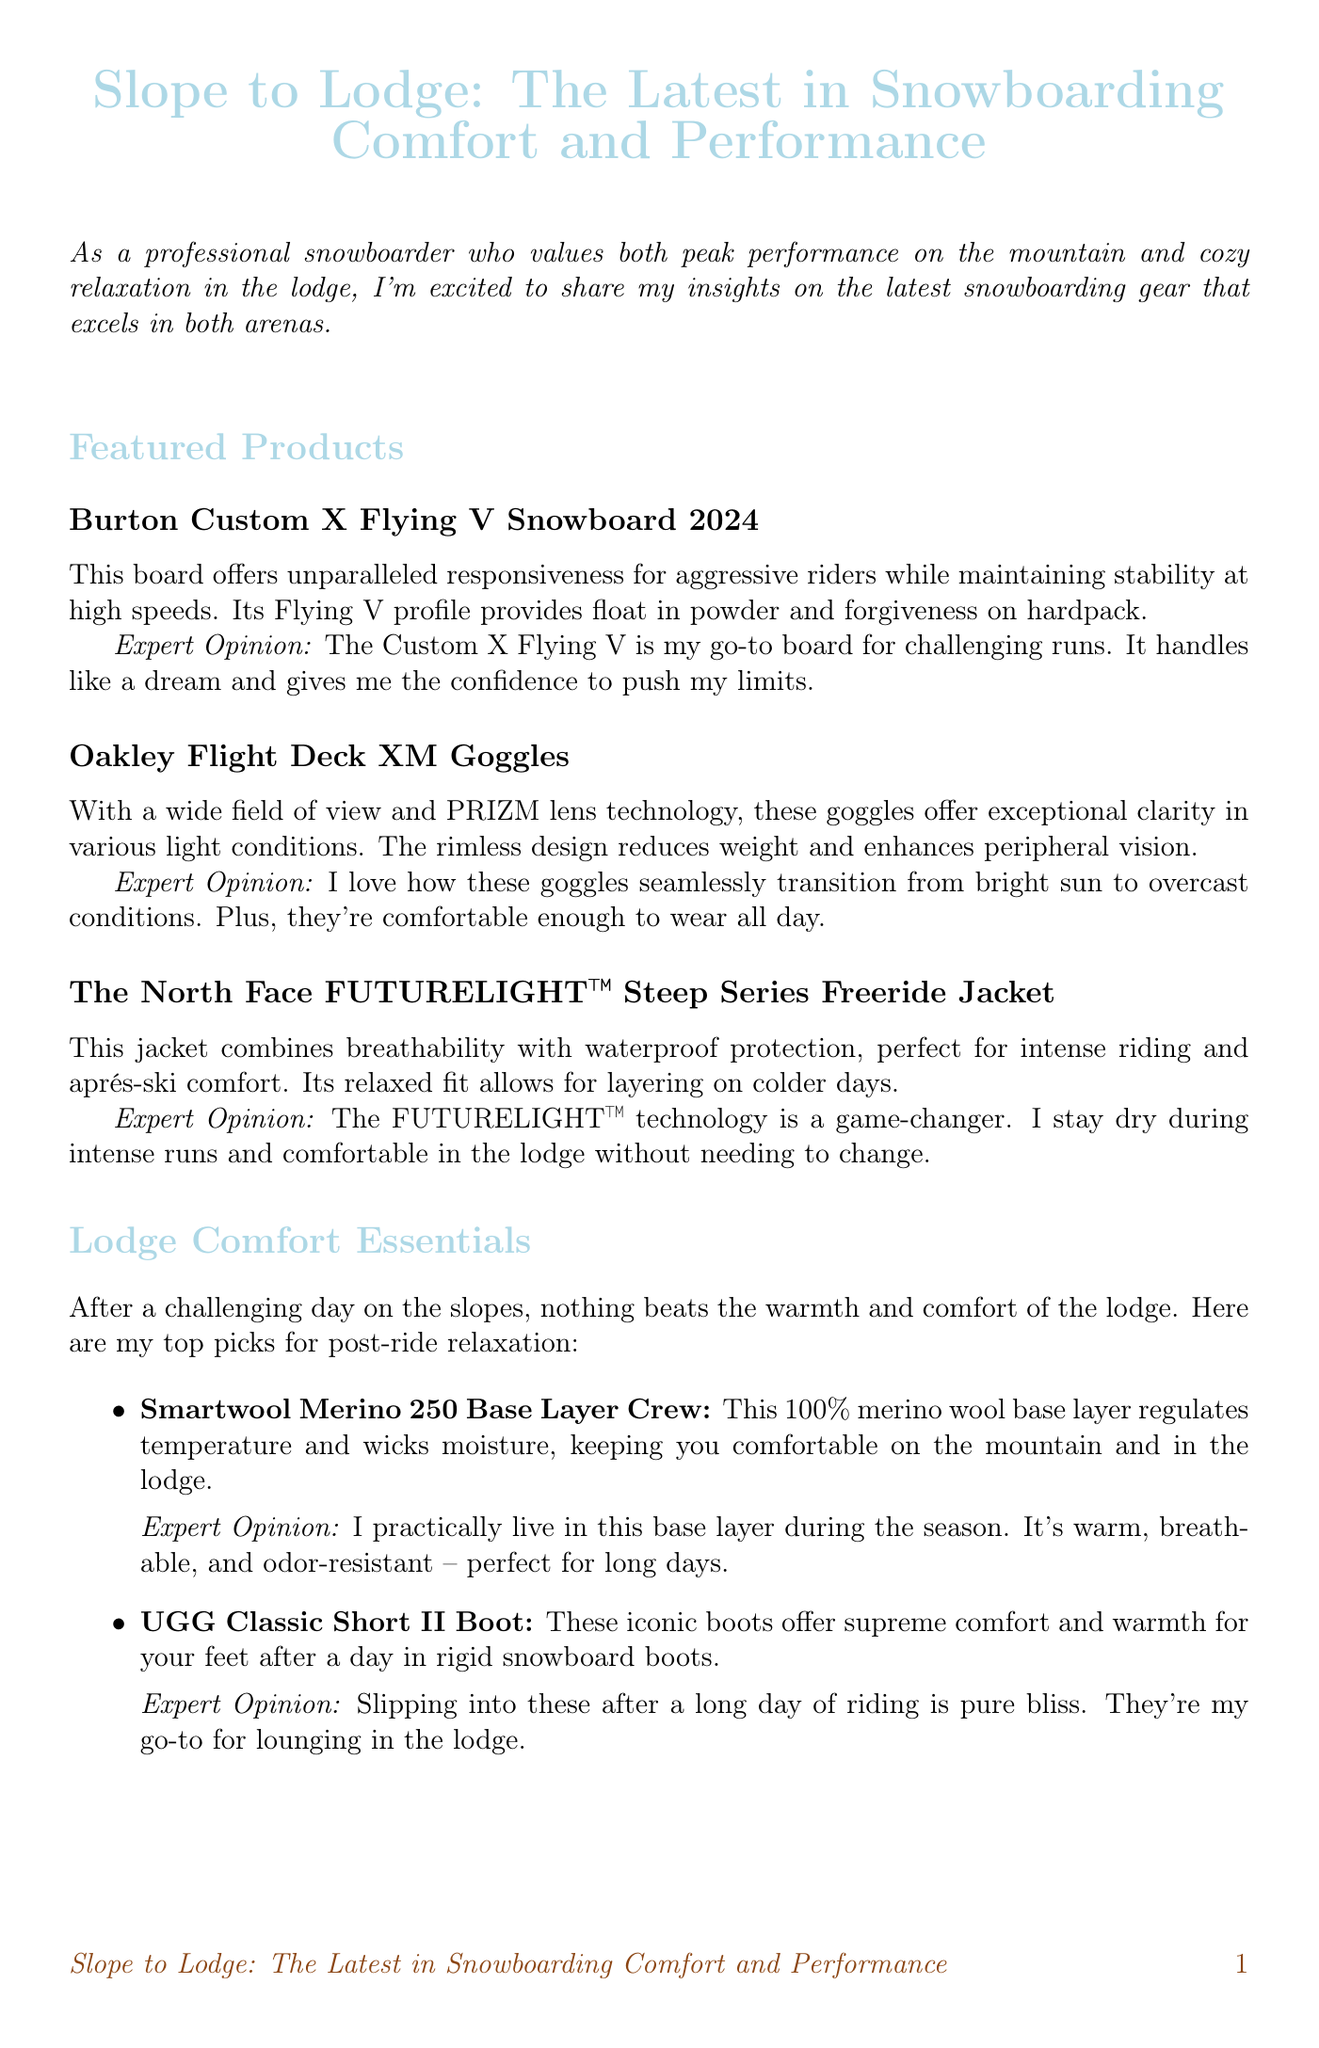What is the title of the newsletter? The title is stated at the beginning of the document and is "Slope to Lodge: The Latest in Snowboarding Comfort and Performance."
Answer: Slope to Lodge: The Latest in Snowboarding Comfort and Performance Who is the target audience for the newsletter? The introduction mentions that it is for a professional snowboarder who values performance and relaxation.
Answer: Professional snowboarder What is the name of the featured snowboard? The document lists specific products in the featured section where the snowboard is mentioned.
Answer: Burton Custom X Flying V Snowboard 2024 What technology do the Oakley goggles feature? The description of the goggles highlights the PRIZM lens technology specifically.
Answer: PRIZM lens technology What is the main function of the Black Diamond Guide BT Avalanche Beacon? The tech corner explains that it is designed for avalanche safety.
Answer: Avalanche safety How does the Smartwool base layer enhance comfort? The document mentions that the base layer regulates temperature and wicks moisture.
Answer: Regulates temperature and wicks moisture Which boot is recommended for post-ride relaxation? The section on lodge comfort essentials specifies the boot recommended for comfort after riding.
Answer: UGG Classic Short II Boot What type of jacket is featured in the newsletter? The featured product section lists the type of jacket as the North Face FUTURELIGHT™ Steep Series Freeride Jacket.
Answer: Freeride jacket What color is primarily used for headings in the document? The formatting of the document indicates that headings are in the specified color called snowblue.
Answer: Snowblue 